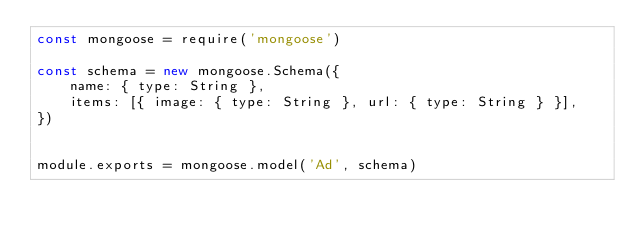<code> <loc_0><loc_0><loc_500><loc_500><_JavaScript_>const mongoose = require('mongoose')

const schema = new mongoose.Schema({
    name: { type: String },
    items: [{ image: { type: String }, url: { type: String } }],
})


module.exports = mongoose.model('Ad', schema)</code> 